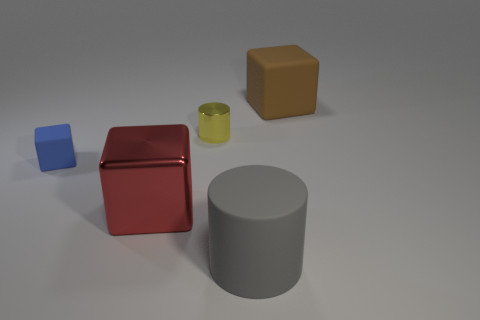What color is the rubber block that is to the left of the yellow metal object? The rubber block to the left of the yellow metal object is blue, showcasing a vibrant shade that stands out against the neutral background of the setting. 